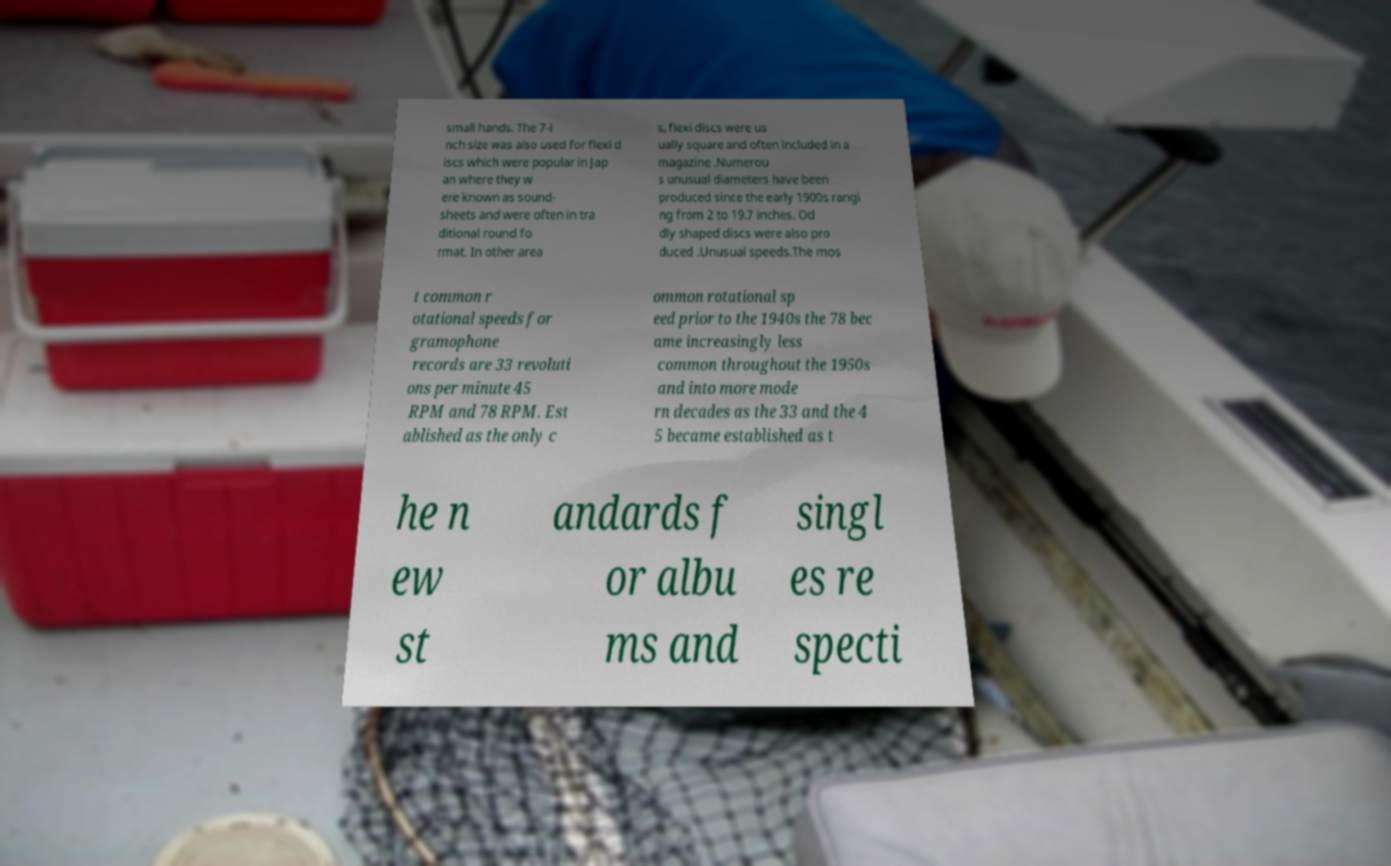Please read and relay the text visible in this image. What does it say? small hands. The 7-i nch size was also used for flexi d iscs which were popular in Jap an where they w ere known as sound- sheets and were often in tra ditional round fo rmat. In other area s, flexi discs were us ually square and often included in a magazine .Numerou s unusual diameters have been produced since the early 1900s rangi ng from 2 to 19.7 inches. Od dly shaped discs were also pro duced .Unusual speeds.The mos t common r otational speeds for gramophone records are 33 revoluti ons per minute 45 RPM and 78 RPM. Est ablished as the only c ommon rotational sp eed prior to the 1940s the 78 bec ame increasingly less common throughout the 1950s and into more mode rn decades as the 33 and the 4 5 became established as t he n ew st andards f or albu ms and singl es re specti 